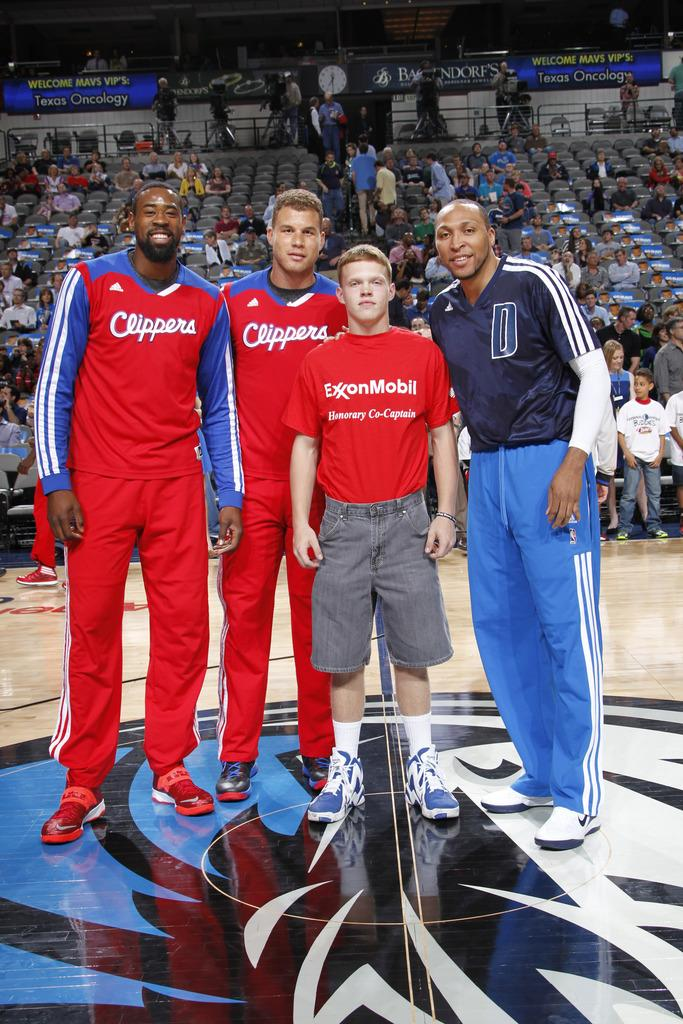<image>
Render a clear and concise summary of the photo. Players taking a photo with a boy wearing a shirt which says ExxonMobil. 